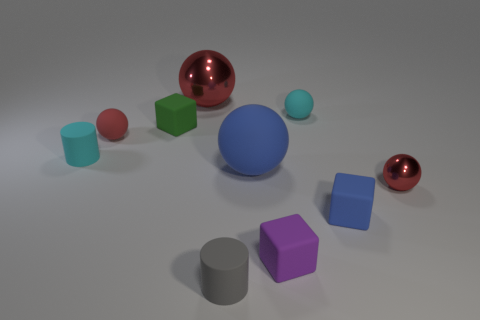Subtract all green cubes. How many red spheres are left? 3 Subtract 3 spheres. How many spheres are left? 2 Subtract all blue balls. How many balls are left? 4 Subtract all blue balls. How many balls are left? 4 Subtract all green balls. Subtract all cyan cylinders. How many balls are left? 5 Subtract all blocks. How many objects are left? 7 Subtract all large blue metal things. Subtract all small purple rubber cubes. How many objects are left? 9 Add 8 big blue rubber balls. How many big blue rubber balls are left? 9 Add 6 matte cylinders. How many matte cylinders exist? 8 Subtract 0 purple cylinders. How many objects are left? 10 